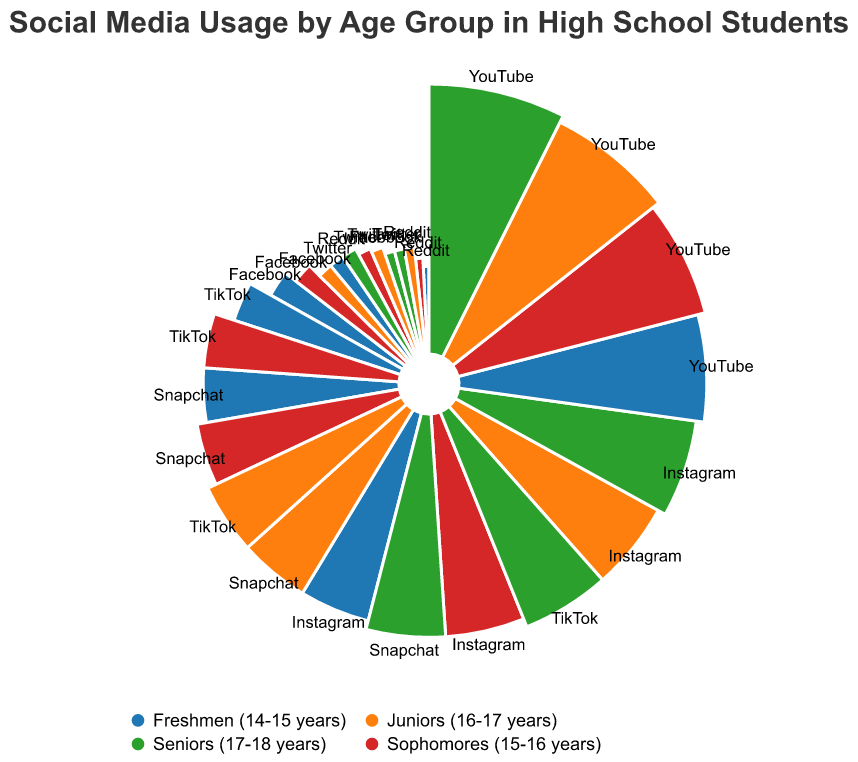What's the most popular social media platform for freshmen? Look for the social media platform with the highest percentage for freshmen. YouTube has the highest value at 80%.
Answer: YouTube Which age group uses TikTok the most? Check the percentages for TikTok across all age groups. Seniors (17-18 years) have the highest percentage at 70%.
Answer: Seniors (17-18 years) How does the usage of Facebook change with age? Examine the percentages of Facebook across the age groups: Freshmen (14-15 years) - 30%, Sophomores (15-16 years) - 25%, Juniors (16-17 years) - 20%, Seniors (17-18 years) - 15%. The usage decreases with age.
Answer: It decreases with age Which two platforms have the closest usage percentages for juniors? Compare the percentages of each platform for juniors: Facebook - 20%, Instagram - 70%, Snapchat - 60%, TikTok - 60%, Twitter - 17%, Reddit - 15%, YouTube - 90%. TikTok and Snapchat both have 60%.
Answer: TikTok and Snapchat What is the average percentage of YouTube usage across all age groups? Add the percentages for YouTube across all age groups and divide by the number of age groups: (80 + 85 + 90 + 95)/4 = 350/4 = 87.5
Answer: 87.5 Compare Instagram usage between sophomores and seniors. By how much does it increase? Find the percentages of Instagram usage for sophomores and seniors: Sophomores - 65%, Seniors - 75%. Calculate the difference: 75 - 65 = 10
Answer: 10 What is the total usage percentage for Reddit across all age groups? Sum the percentages for Reddit across all age groups: 10 (Freshmen) + 12 (Sophomores) + 15 (Juniors) + 20 (Seniors) = 57
Answer: 57 Which platform shows the most significant increase in usage from freshmen to seniors? Calculate the difference in usage for each platform from freshmen to seniors, then identify the platform with the highest increase: 
- Facebook: 30 - 15 = -15 
- Instagram: 75 - 60 = 15 
- Snapchat: 65 - 50 = 15 
- TikTok: 70 - 40 = 30 (highest)
  - Twitter: 15 - 20 = -5 
- Reddit: 20 - 10 = 10 
- YouTube: 95 - 80 = 15
Answer: TikTok How does Twitter usage among freshmen compare to Reddit usage among seniors? Find the percentages of Twitter usage among freshmen and Reddit usage among seniors: Twitter (Freshmen) - 20%, Reddit (Seniors) - 20%. The percentages are equal.
Answer: Equal What's the average percentage for Snapchat usage in freshmen and juniors? Sum the percentages for Snapchat among freshmen and juniors and divide by 2: (50 + 60) / 2 = 110 / 2 = 55
Answer: 55 